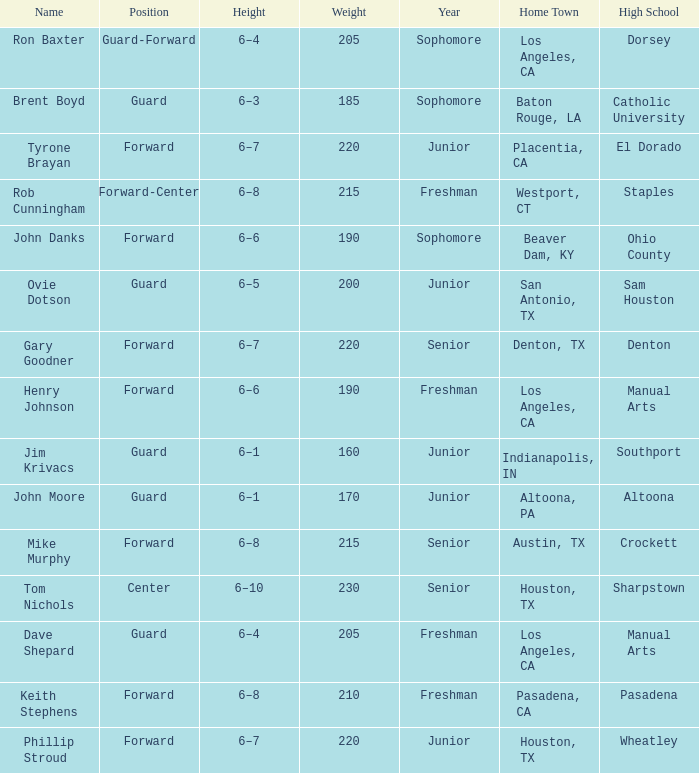What is the Position with a Year with freshman, and a Weight larger than 210? Forward-Center. 